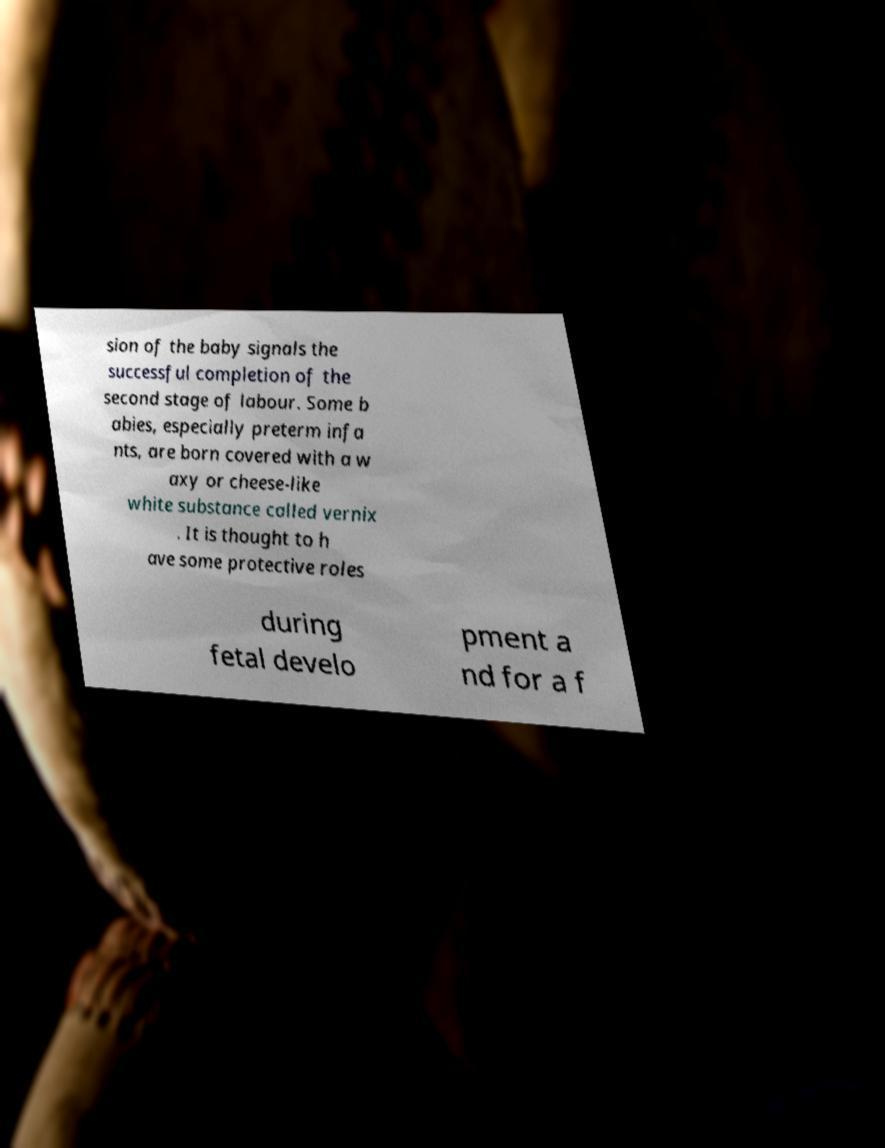What messages or text are displayed in this image? I need them in a readable, typed format. sion of the baby signals the successful completion of the second stage of labour. Some b abies, especially preterm infa nts, are born covered with a w axy or cheese-like white substance called vernix . It is thought to h ave some protective roles during fetal develo pment a nd for a f 